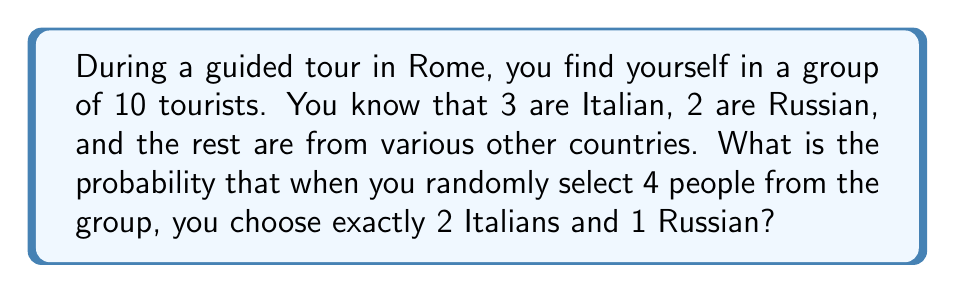Provide a solution to this math problem. Let's approach this step-by-step using the concept of combinations:

1) First, we need to calculate the number of ways to select 4 people out of 10:
   $$\binom{10}{4} = \frac{10!}{4!(10-4)!} = 210$$

2) Now, we need to calculate:
   - The number of ways to select 2 Italians out of 3: $\binom{3}{2}$
   - The number of ways to select 1 Russian out of 2: $\binom{2}{1}$
   - The number of ways to select 1 person from the remaining 5: $\binom{5}{1}$

3) Let's calculate these:
   $$\binom{3}{2} = \frac{3!}{2!(3-2)!} = 3$$
   $$\binom{2}{1} = \frac{2!}{1!(2-1)!} = 2$$
   $$\binom{5}{1} = \frac{5!}{1!(5-1)!} = 5$$

4) The total number of favorable outcomes is the product of these:
   $$3 \times 2 \times 5 = 30$$

5) The probability is the number of favorable outcomes divided by the total number of possible outcomes:
   $$P(\text{2 Italians and 1 Russian}) = \frac{30}{210} = \frac{1}{7}$$
Answer: $\frac{1}{7}$ 